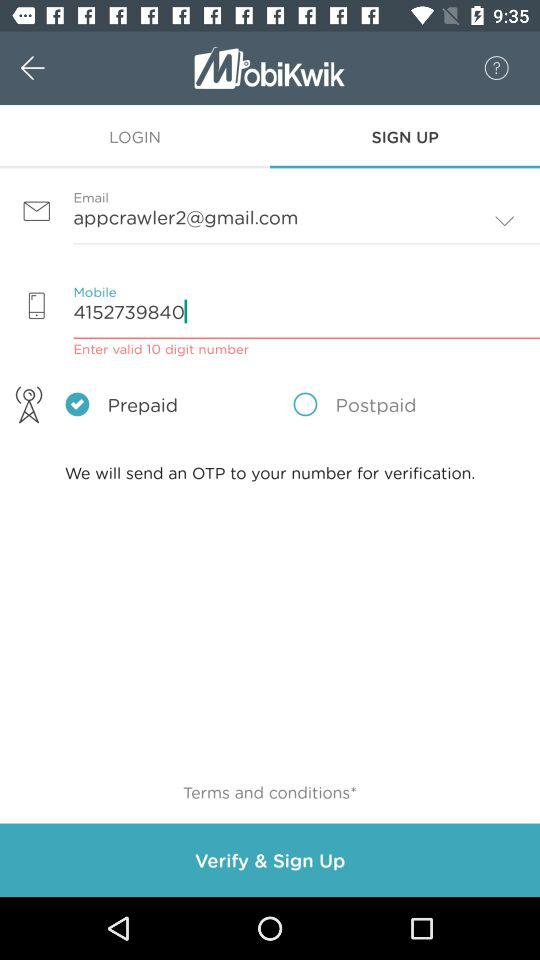What is the mobile number? The mobile number is 4152739840. 